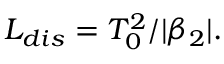Convert formula to latex. <formula><loc_0><loc_0><loc_500><loc_500>L _ { d i s } = T _ { 0 } ^ { 2 } / | \beta _ { 2 } | .</formula> 